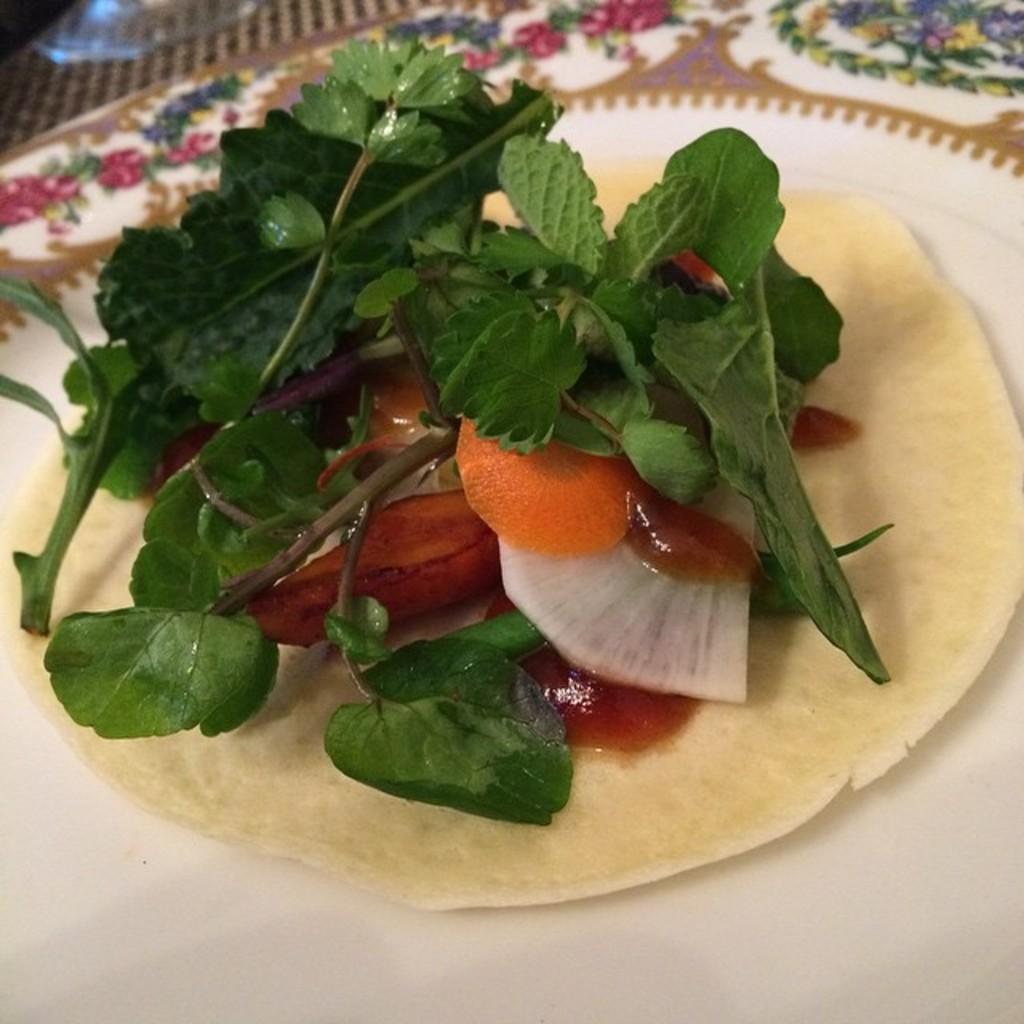Please provide a concise description of this image. Here in this picture we can see some leafy vegetables and other vegetables present on the plate, which is present on the table over there. 